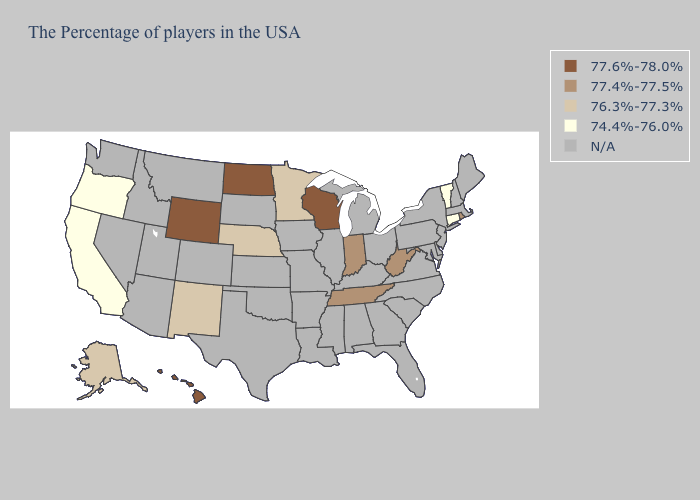Name the states that have a value in the range 77.4%-77.5%?
Concise answer only. Rhode Island, West Virginia, Indiana, Tennessee. Does North Dakota have the highest value in the USA?
Keep it brief. Yes. What is the lowest value in the MidWest?
Write a very short answer. 76.3%-77.3%. What is the lowest value in the USA?
Short answer required. 74.4%-76.0%. Does Wisconsin have the lowest value in the USA?
Answer briefly. No. What is the highest value in states that border Montana?
Give a very brief answer. 77.6%-78.0%. Is the legend a continuous bar?
Quick response, please. No. What is the value of Indiana?
Give a very brief answer. 77.4%-77.5%. Name the states that have a value in the range 76.3%-77.3%?
Quick response, please. Minnesota, Nebraska, New Mexico, Alaska. Name the states that have a value in the range 74.4%-76.0%?
Keep it brief. Vermont, Connecticut, California, Oregon. Name the states that have a value in the range 77.4%-77.5%?
Short answer required. Rhode Island, West Virginia, Indiana, Tennessee. Does Connecticut have the highest value in the Northeast?
Give a very brief answer. No. What is the lowest value in the MidWest?
Write a very short answer. 76.3%-77.3%. Does the first symbol in the legend represent the smallest category?
Concise answer only. No. 